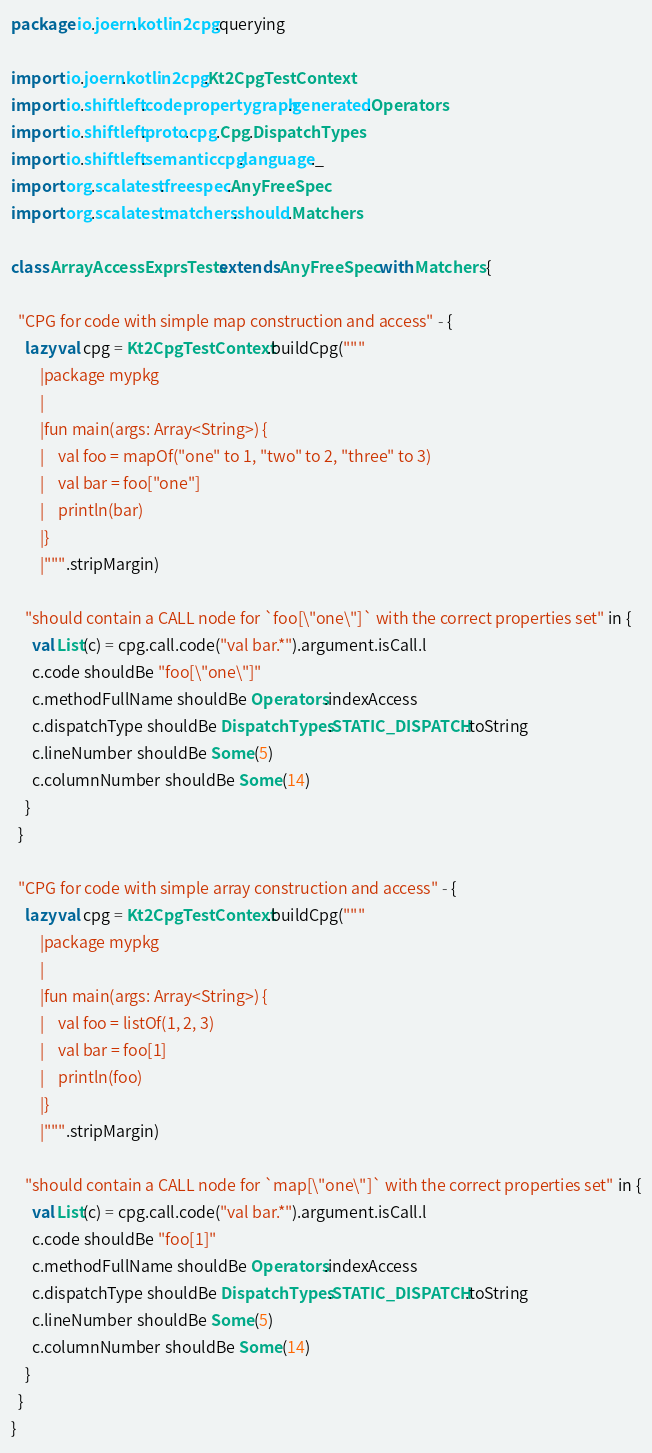<code> <loc_0><loc_0><loc_500><loc_500><_Scala_>package io.joern.kotlin2cpg.querying

import io.joern.kotlin2cpg.Kt2CpgTestContext
import io.shiftleft.codepropertygraph.generated.Operators
import io.shiftleft.proto.cpg.Cpg.DispatchTypes
import io.shiftleft.semanticcpg.language._
import org.scalatest.freespec.AnyFreeSpec
import org.scalatest.matchers.should.Matchers

class ArrayAccessExprsTests extends AnyFreeSpec with Matchers {

  "CPG for code with simple map construction and access" - {
    lazy val cpg = Kt2CpgTestContext.buildCpg("""
        |package mypkg
        |
        |fun main(args: Array<String>) {
        |    val foo = mapOf("one" to 1, "two" to 2, "three" to 3)
        |    val bar = foo["one"]
        |    println(bar)
        |}
        |""".stripMargin)

    "should contain a CALL node for `foo[\"one\"]` with the correct properties set" in {
      val List(c) = cpg.call.code("val bar.*").argument.isCall.l
      c.code shouldBe "foo[\"one\"]"
      c.methodFullName shouldBe Operators.indexAccess
      c.dispatchType shouldBe DispatchTypes.STATIC_DISPATCH.toString
      c.lineNumber shouldBe Some(5)
      c.columnNumber shouldBe Some(14)
    }
  }

  "CPG for code with simple array construction and access" - {
    lazy val cpg = Kt2CpgTestContext.buildCpg("""
        |package mypkg
        |
        |fun main(args: Array<String>) {
        |    val foo = listOf(1, 2, 3)
        |    val bar = foo[1]
        |    println(foo)
        |}
        |""".stripMargin)

    "should contain a CALL node for `map[\"one\"]` with the correct properties set" in {
      val List(c) = cpg.call.code("val bar.*").argument.isCall.l
      c.code shouldBe "foo[1]"
      c.methodFullName shouldBe Operators.indexAccess
      c.dispatchType shouldBe DispatchTypes.STATIC_DISPATCH.toString
      c.lineNumber shouldBe Some(5)
      c.columnNumber shouldBe Some(14)
    }
  }
}
</code> 